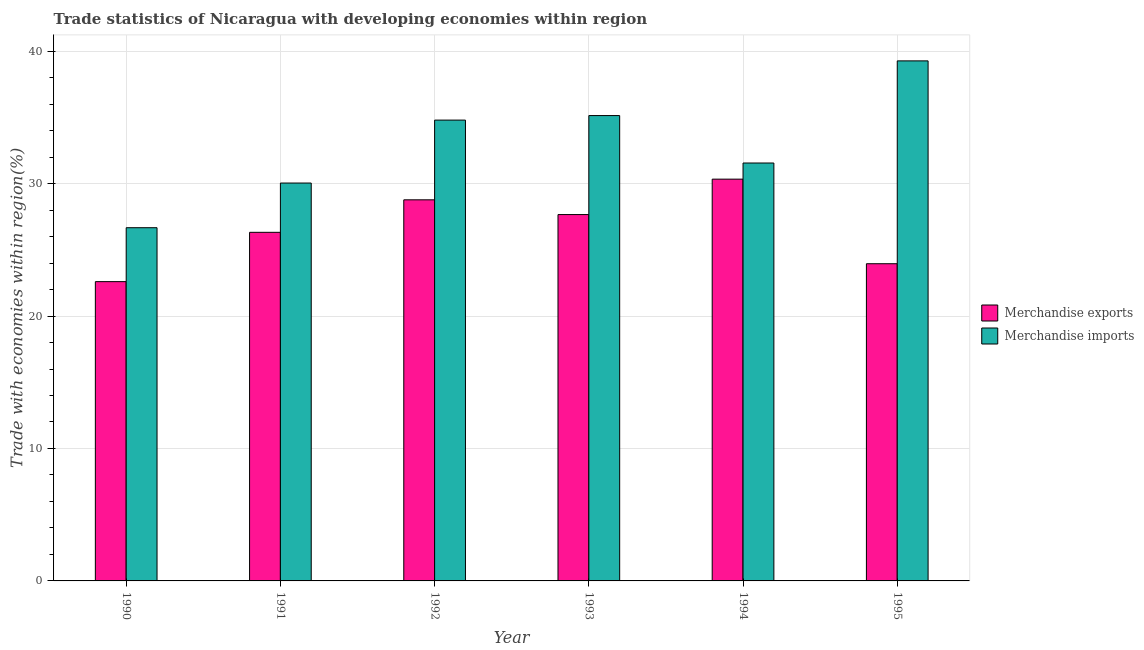How many different coloured bars are there?
Offer a terse response. 2. Are the number of bars on each tick of the X-axis equal?
Give a very brief answer. Yes. How many bars are there on the 2nd tick from the right?
Provide a short and direct response. 2. What is the label of the 5th group of bars from the left?
Provide a short and direct response. 1994. What is the merchandise imports in 1994?
Your response must be concise. 31.55. Across all years, what is the maximum merchandise exports?
Your answer should be very brief. 30.33. Across all years, what is the minimum merchandise exports?
Your response must be concise. 22.6. In which year was the merchandise exports minimum?
Offer a very short reply. 1990. What is the total merchandise imports in the graph?
Give a very brief answer. 197.45. What is the difference between the merchandise exports in 1990 and that in 1994?
Give a very brief answer. -7.74. What is the difference between the merchandise imports in 1991 and the merchandise exports in 1995?
Your answer should be very brief. -9.22. What is the average merchandise imports per year?
Provide a short and direct response. 32.91. What is the ratio of the merchandise exports in 1991 to that in 1993?
Your answer should be very brief. 0.95. Is the merchandise exports in 1991 less than that in 1995?
Provide a short and direct response. No. What is the difference between the highest and the second highest merchandise exports?
Your answer should be very brief. 1.56. What is the difference between the highest and the lowest merchandise exports?
Keep it short and to the point. 7.74. Is the sum of the merchandise imports in 1993 and 1995 greater than the maximum merchandise exports across all years?
Give a very brief answer. Yes. What does the 2nd bar from the left in 1992 represents?
Provide a succinct answer. Merchandise imports. How many years are there in the graph?
Ensure brevity in your answer.  6. Are the values on the major ticks of Y-axis written in scientific E-notation?
Your answer should be compact. No. What is the title of the graph?
Offer a very short reply. Trade statistics of Nicaragua with developing economies within region. Does "Mobile cellular" appear as one of the legend labels in the graph?
Your response must be concise. No. What is the label or title of the X-axis?
Give a very brief answer. Year. What is the label or title of the Y-axis?
Provide a succinct answer. Trade with economies within region(%). What is the Trade with economies within region(%) in Merchandise exports in 1990?
Ensure brevity in your answer.  22.6. What is the Trade with economies within region(%) of Merchandise imports in 1990?
Keep it short and to the point. 26.67. What is the Trade with economies within region(%) in Merchandise exports in 1991?
Ensure brevity in your answer.  26.32. What is the Trade with economies within region(%) in Merchandise imports in 1991?
Give a very brief answer. 30.04. What is the Trade with economies within region(%) of Merchandise exports in 1992?
Your response must be concise. 28.77. What is the Trade with economies within region(%) in Merchandise imports in 1992?
Provide a short and direct response. 34.79. What is the Trade with economies within region(%) of Merchandise exports in 1993?
Give a very brief answer. 27.66. What is the Trade with economies within region(%) of Merchandise imports in 1993?
Your response must be concise. 35.13. What is the Trade with economies within region(%) of Merchandise exports in 1994?
Offer a terse response. 30.33. What is the Trade with economies within region(%) in Merchandise imports in 1994?
Offer a terse response. 31.55. What is the Trade with economies within region(%) of Merchandise exports in 1995?
Ensure brevity in your answer.  23.95. What is the Trade with economies within region(%) of Merchandise imports in 1995?
Make the answer very short. 39.26. Across all years, what is the maximum Trade with economies within region(%) of Merchandise exports?
Your response must be concise. 30.33. Across all years, what is the maximum Trade with economies within region(%) of Merchandise imports?
Offer a very short reply. 39.26. Across all years, what is the minimum Trade with economies within region(%) in Merchandise exports?
Provide a short and direct response. 22.6. Across all years, what is the minimum Trade with economies within region(%) of Merchandise imports?
Your response must be concise. 26.67. What is the total Trade with economies within region(%) of Merchandise exports in the graph?
Keep it short and to the point. 159.63. What is the total Trade with economies within region(%) in Merchandise imports in the graph?
Offer a terse response. 197.45. What is the difference between the Trade with economies within region(%) of Merchandise exports in 1990 and that in 1991?
Provide a succinct answer. -3.72. What is the difference between the Trade with economies within region(%) of Merchandise imports in 1990 and that in 1991?
Your answer should be compact. -3.37. What is the difference between the Trade with economies within region(%) of Merchandise exports in 1990 and that in 1992?
Ensure brevity in your answer.  -6.18. What is the difference between the Trade with economies within region(%) in Merchandise imports in 1990 and that in 1992?
Ensure brevity in your answer.  -8.13. What is the difference between the Trade with economies within region(%) of Merchandise exports in 1990 and that in 1993?
Offer a terse response. -5.06. What is the difference between the Trade with economies within region(%) in Merchandise imports in 1990 and that in 1993?
Offer a very short reply. -8.47. What is the difference between the Trade with economies within region(%) in Merchandise exports in 1990 and that in 1994?
Your response must be concise. -7.74. What is the difference between the Trade with economies within region(%) in Merchandise imports in 1990 and that in 1994?
Your answer should be compact. -4.88. What is the difference between the Trade with economies within region(%) in Merchandise exports in 1990 and that in 1995?
Keep it short and to the point. -1.35. What is the difference between the Trade with economies within region(%) in Merchandise imports in 1990 and that in 1995?
Offer a terse response. -12.6. What is the difference between the Trade with economies within region(%) of Merchandise exports in 1991 and that in 1992?
Provide a short and direct response. -2.45. What is the difference between the Trade with economies within region(%) of Merchandise imports in 1991 and that in 1992?
Offer a terse response. -4.75. What is the difference between the Trade with economies within region(%) of Merchandise exports in 1991 and that in 1993?
Ensure brevity in your answer.  -1.34. What is the difference between the Trade with economies within region(%) in Merchandise imports in 1991 and that in 1993?
Your answer should be very brief. -5.09. What is the difference between the Trade with economies within region(%) of Merchandise exports in 1991 and that in 1994?
Offer a very short reply. -4.01. What is the difference between the Trade with economies within region(%) of Merchandise imports in 1991 and that in 1994?
Ensure brevity in your answer.  -1.51. What is the difference between the Trade with economies within region(%) in Merchandise exports in 1991 and that in 1995?
Offer a very short reply. 2.37. What is the difference between the Trade with economies within region(%) of Merchandise imports in 1991 and that in 1995?
Offer a terse response. -9.22. What is the difference between the Trade with economies within region(%) of Merchandise exports in 1992 and that in 1993?
Make the answer very short. 1.11. What is the difference between the Trade with economies within region(%) of Merchandise imports in 1992 and that in 1993?
Give a very brief answer. -0.34. What is the difference between the Trade with economies within region(%) in Merchandise exports in 1992 and that in 1994?
Offer a very short reply. -1.56. What is the difference between the Trade with economies within region(%) of Merchandise imports in 1992 and that in 1994?
Your response must be concise. 3.24. What is the difference between the Trade with economies within region(%) of Merchandise exports in 1992 and that in 1995?
Make the answer very short. 4.83. What is the difference between the Trade with economies within region(%) of Merchandise imports in 1992 and that in 1995?
Offer a very short reply. -4.47. What is the difference between the Trade with economies within region(%) of Merchandise exports in 1993 and that in 1994?
Provide a short and direct response. -2.67. What is the difference between the Trade with economies within region(%) of Merchandise imports in 1993 and that in 1994?
Offer a very short reply. 3.58. What is the difference between the Trade with economies within region(%) in Merchandise exports in 1993 and that in 1995?
Your response must be concise. 3.71. What is the difference between the Trade with economies within region(%) of Merchandise imports in 1993 and that in 1995?
Your answer should be compact. -4.13. What is the difference between the Trade with economies within region(%) of Merchandise exports in 1994 and that in 1995?
Offer a terse response. 6.39. What is the difference between the Trade with economies within region(%) of Merchandise imports in 1994 and that in 1995?
Ensure brevity in your answer.  -7.71. What is the difference between the Trade with economies within region(%) in Merchandise exports in 1990 and the Trade with economies within region(%) in Merchandise imports in 1991?
Your response must be concise. -7.44. What is the difference between the Trade with economies within region(%) in Merchandise exports in 1990 and the Trade with economies within region(%) in Merchandise imports in 1992?
Make the answer very short. -12.2. What is the difference between the Trade with economies within region(%) of Merchandise exports in 1990 and the Trade with economies within region(%) of Merchandise imports in 1993?
Give a very brief answer. -12.54. What is the difference between the Trade with economies within region(%) of Merchandise exports in 1990 and the Trade with economies within region(%) of Merchandise imports in 1994?
Your answer should be compact. -8.96. What is the difference between the Trade with economies within region(%) in Merchandise exports in 1990 and the Trade with economies within region(%) in Merchandise imports in 1995?
Your answer should be very brief. -16.67. What is the difference between the Trade with economies within region(%) of Merchandise exports in 1991 and the Trade with economies within region(%) of Merchandise imports in 1992?
Make the answer very short. -8.47. What is the difference between the Trade with economies within region(%) of Merchandise exports in 1991 and the Trade with economies within region(%) of Merchandise imports in 1993?
Your answer should be very brief. -8.81. What is the difference between the Trade with economies within region(%) of Merchandise exports in 1991 and the Trade with economies within region(%) of Merchandise imports in 1994?
Offer a terse response. -5.23. What is the difference between the Trade with economies within region(%) of Merchandise exports in 1991 and the Trade with economies within region(%) of Merchandise imports in 1995?
Ensure brevity in your answer.  -12.94. What is the difference between the Trade with economies within region(%) of Merchandise exports in 1992 and the Trade with economies within region(%) of Merchandise imports in 1993?
Provide a short and direct response. -6.36. What is the difference between the Trade with economies within region(%) in Merchandise exports in 1992 and the Trade with economies within region(%) in Merchandise imports in 1994?
Your response must be concise. -2.78. What is the difference between the Trade with economies within region(%) of Merchandise exports in 1992 and the Trade with economies within region(%) of Merchandise imports in 1995?
Your answer should be compact. -10.49. What is the difference between the Trade with economies within region(%) in Merchandise exports in 1993 and the Trade with economies within region(%) in Merchandise imports in 1994?
Your answer should be compact. -3.89. What is the difference between the Trade with economies within region(%) of Merchandise exports in 1993 and the Trade with economies within region(%) of Merchandise imports in 1995?
Ensure brevity in your answer.  -11.6. What is the difference between the Trade with economies within region(%) of Merchandise exports in 1994 and the Trade with economies within region(%) of Merchandise imports in 1995?
Keep it short and to the point. -8.93. What is the average Trade with economies within region(%) of Merchandise exports per year?
Offer a very short reply. 26.61. What is the average Trade with economies within region(%) of Merchandise imports per year?
Provide a succinct answer. 32.91. In the year 1990, what is the difference between the Trade with economies within region(%) in Merchandise exports and Trade with economies within region(%) in Merchandise imports?
Keep it short and to the point. -4.07. In the year 1991, what is the difference between the Trade with economies within region(%) in Merchandise exports and Trade with economies within region(%) in Merchandise imports?
Your answer should be very brief. -3.72. In the year 1992, what is the difference between the Trade with economies within region(%) of Merchandise exports and Trade with economies within region(%) of Merchandise imports?
Make the answer very short. -6.02. In the year 1993, what is the difference between the Trade with economies within region(%) in Merchandise exports and Trade with economies within region(%) in Merchandise imports?
Ensure brevity in your answer.  -7.47. In the year 1994, what is the difference between the Trade with economies within region(%) of Merchandise exports and Trade with economies within region(%) of Merchandise imports?
Provide a succinct answer. -1.22. In the year 1995, what is the difference between the Trade with economies within region(%) of Merchandise exports and Trade with economies within region(%) of Merchandise imports?
Keep it short and to the point. -15.32. What is the ratio of the Trade with economies within region(%) in Merchandise exports in 1990 to that in 1991?
Provide a short and direct response. 0.86. What is the ratio of the Trade with economies within region(%) of Merchandise imports in 1990 to that in 1991?
Give a very brief answer. 0.89. What is the ratio of the Trade with economies within region(%) in Merchandise exports in 1990 to that in 1992?
Your response must be concise. 0.79. What is the ratio of the Trade with economies within region(%) of Merchandise imports in 1990 to that in 1992?
Offer a terse response. 0.77. What is the ratio of the Trade with economies within region(%) of Merchandise exports in 1990 to that in 1993?
Your answer should be very brief. 0.82. What is the ratio of the Trade with economies within region(%) of Merchandise imports in 1990 to that in 1993?
Ensure brevity in your answer.  0.76. What is the ratio of the Trade with economies within region(%) of Merchandise exports in 1990 to that in 1994?
Give a very brief answer. 0.74. What is the ratio of the Trade with economies within region(%) of Merchandise imports in 1990 to that in 1994?
Your answer should be compact. 0.85. What is the ratio of the Trade with economies within region(%) in Merchandise exports in 1990 to that in 1995?
Your response must be concise. 0.94. What is the ratio of the Trade with economies within region(%) of Merchandise imports in 1990 to that in 1995?
Keep it short and to the point. 0.68. What is the ratio of the Trade with economies within region(%) of Merchandise exports in 1991 to that in 1992?
Give a very brief answer. 0.91. What is the ratio of the Trade with economies within region(%) of Merchandise imports in 1991 to that in 1992?
Your answer should be very brief. 0.86. What is the ratio of the Trade with economies within region(%) in Merchandise exports in 1991 to that in 1993?
Provide a short and direct response. 0.95. What is the ratio of the Trade with economies within region(%) of Merchandise imports in 1991 to that in 1993?
Your response must be concise. 0.85. What is the ratio of the Trade with economies within region(%) of Merchandise exports in 1991 to that in 1994?
Make the answer very short. 0.87. What is the ratio of the Trade with economies within region(%) in Merchandise imports in 1991 to that in 1994?
Give a very brief answer. 0.95. What is the ratio of the Trade with economies within region(%) in Merchandise exports in 1991 to that in 1995?
Offer a very short reply. 1.1. What is the ratio of the Trade with economies within region(%) of Merchandise imports in 1991 to that in 1995?
Your response must be concise. 0.77. What is the ratio of the Trade with economies within region(%) of Merchandise exports in 1992 to that in 1993?
Make the answer very short. 1.04. What is the ratio of the Trade with economies within region(%) in Merchandise imports in 1992 to that in 1993?
Offer a very short reply. 0.99. What is the ratio of the Trade with economies within region(%) in Merchandise exports in 1992 to that in 1994?
Provide a succinct answer. 0.95. What is the ratio of the Trade with economies within region(%) of Merchandise imports in 1992 to that in 1994?
Your answer should be very brief. 1.1. What is the ratio of the Trade with economies within region(%) of Merchandise exports in 1992 to that in 1995?
Provide a short and direct response. 1.2. What is the ratio of the Trade with economies within region(%) of Merchandise imports in 1992 to that in 1995?
Make the answer very short. 0.89. What is the ratio of the Trade with economies within region(%) of Merchandise exports in 1993 to that in 1994?
Give a very brief answer. 0.91. What is the ratio of the Trade with economies within region(%) in Merchandise imports in 1993 to that in 1994?
Ensure brevity in your answer.  1.11. What is the ratio of the Trade with economies within region(%) in Merchandise exports in 1993 to that in 1995?
Provide a short and direct response. 1.16. What is the ratio of the Trade with economies within region(%) in Merchandise imports in 1993 to that in 1995?
Offer a terse response. 0.89. What is the ratio of the Trade with economies within region(%) in Merchandise exports in 1994 to that in 1995?
Provide a succinct answer. 1.27. What is the ratio of the Trade with economies within region(%) in Merchandise imports in 1994 to that in 1995?
Offer a terse response. 0.8. What is the difference between the highest and the second highest Trade with economies within region(%) of Merchandise exports?
Give a very brief answer. 1.56. What is the difference between the highest and the second highest Trade with economies within region(%) of Merchandise imports?
Ensure brevity in your answer.  4.13. What is the difference between the highest and the lowest Trade with economies within region(%) of Merchandise exports?
Provide a short and direct response. 7.74. What is the difference between the highest and the lowest Trade with economies within region(%) of Merchandise imports?
Your response must be concise. 12.6. 